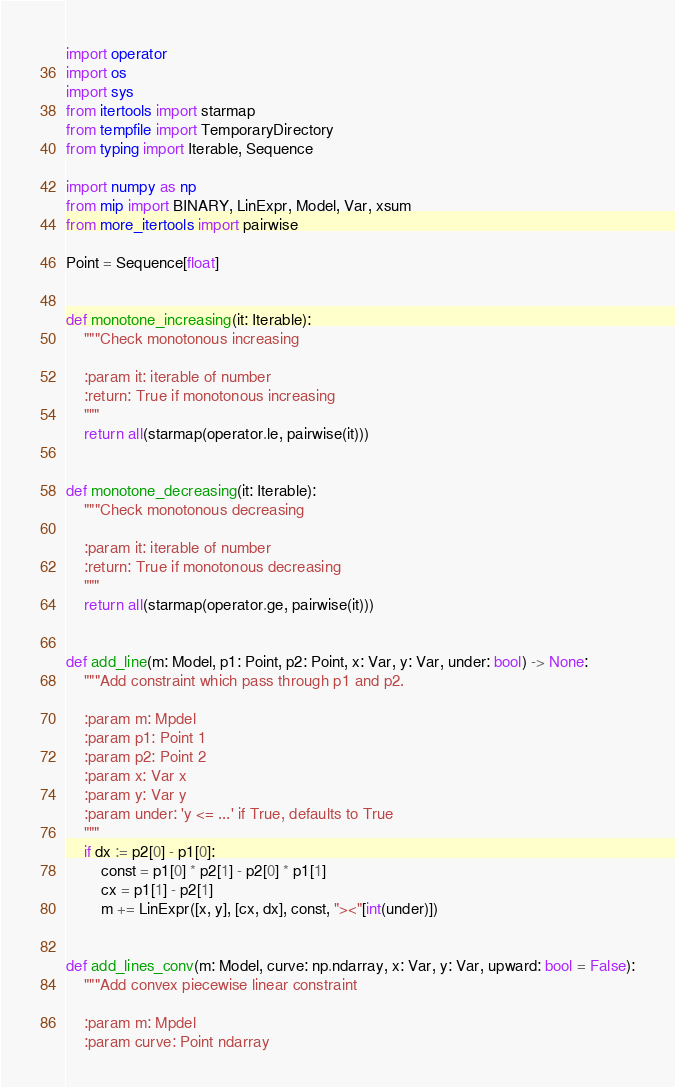Convert code to text. <code><loc_0><loc_0><loc_500><loc_500><_Python_>import operator
import os
import sys
from itertools import starmap
from tempfile import TemporaryDirectory
from typing import Iterable, Sequence

import numpy as np
from mip import BINARY, LinExpr, Model, Var, xsum
from more_itertools import pairwise

Point = Sequence[float]


def monotone_increasing(it: Iterable):
    """Check monotonous increasing

    :param it: iterable of number
    :return: True if monotonous increasing
    """
    return all(starmap(operator.le, pairwise(it)))


def monotone_decreasing(it: Iterable):
    """Check monotonous decreasing

    :param it: iterable of number
    :return: True if monotonous decreasing
    """
    return all(starmap(operator.ge, pairwise(it)))


def add_line(m: Model, p1: Point, p2: Point, x: Var, y: Var, under: bool) -> None:
    """Add constraint which pass through p1 and p2.

    :param m: Mpdel
    :param p1: Point 1
    :param p2: Point 2
    :param x: Var x
    :param y: Var y
    :param under: 'y <= ...' if True, defaults to True
    """
    if dx := p2[0] - p1[0]:
        const = p1[0] * p2[1] - p2[0] * p1[1]
        cx = p1[1] - p2[1]
        m += LinExpr([x, y], [cx, dx], const, "><"[int(under)])


def add_lines_conv(m: Model, curve: np.ndarray, x: Var, y: Var, upward: bool = False):
    """Add convex piecewise linear constraint

    :param m: Mpdel
    :param curve: Point ndarray</code> 